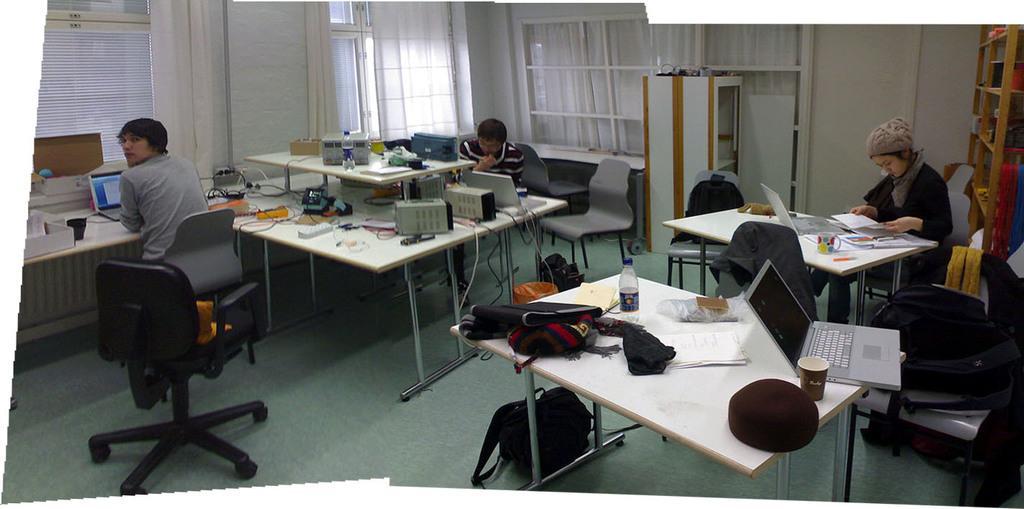Please provide a concise description of this image. This image is taken inside a room. There are three people in this room. In the left side of the image a man is sitting on a chair and placing his hands on desk. In the right side of the image a woman is sitting on a chair and looking at a book which is on the table. At the bottom of the image there is a floor with mat and a bag. In the middle of the image there is a table and there were few things on it. At the background there is a wall with window blinds, windows and curtains. 